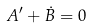Convert formula to latex. <formula><loc_0><loc_0><loc_500><loc_500>A ^ { \prime } + \dot { B } = 0</formula> 